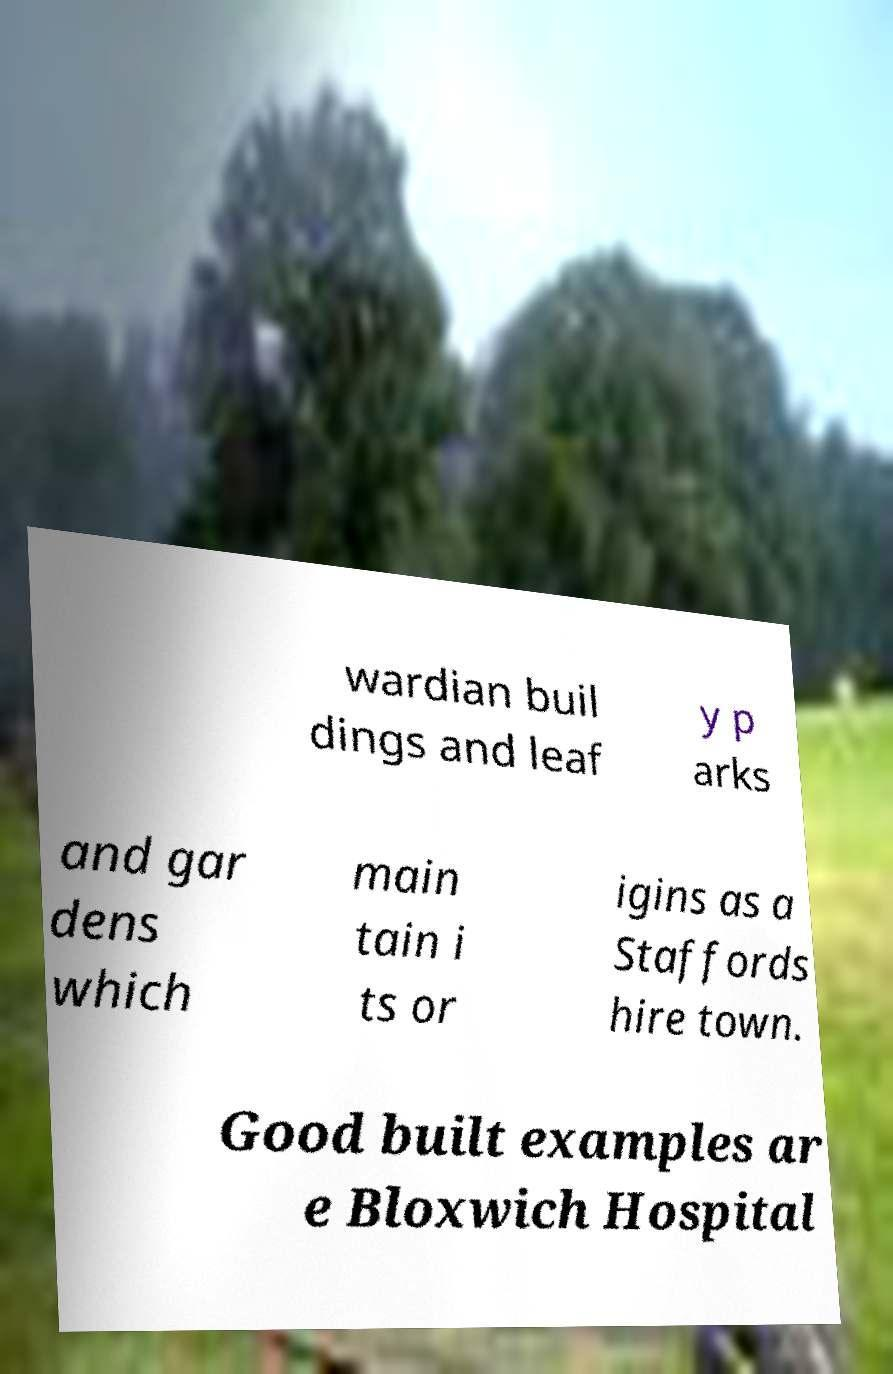Could you assist in decoding the text presented in this image and type it out clearly? wardian buil dings and leaf y p arks and gar dens which main tain i ts or igins as a Staffords hire town. Good built examples ar e Bloxwich Hospital 